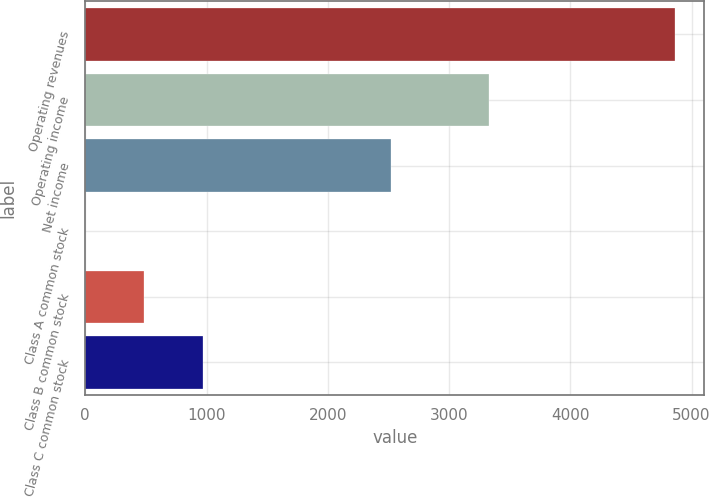<chart> <loc_0><loc_0><loc_500><loc_500><bar_chart><fcel>Operating revenues<fcel>Operating income<fcel>Net income<fcel>Class A common stock<fcel>Class B common stock<fcel>Class C common stock<nl><fcel>4862<fcel>3327<fcel>2522<fcel>1.07<fcel>487.16<fcel>973.25<nl></chart> 